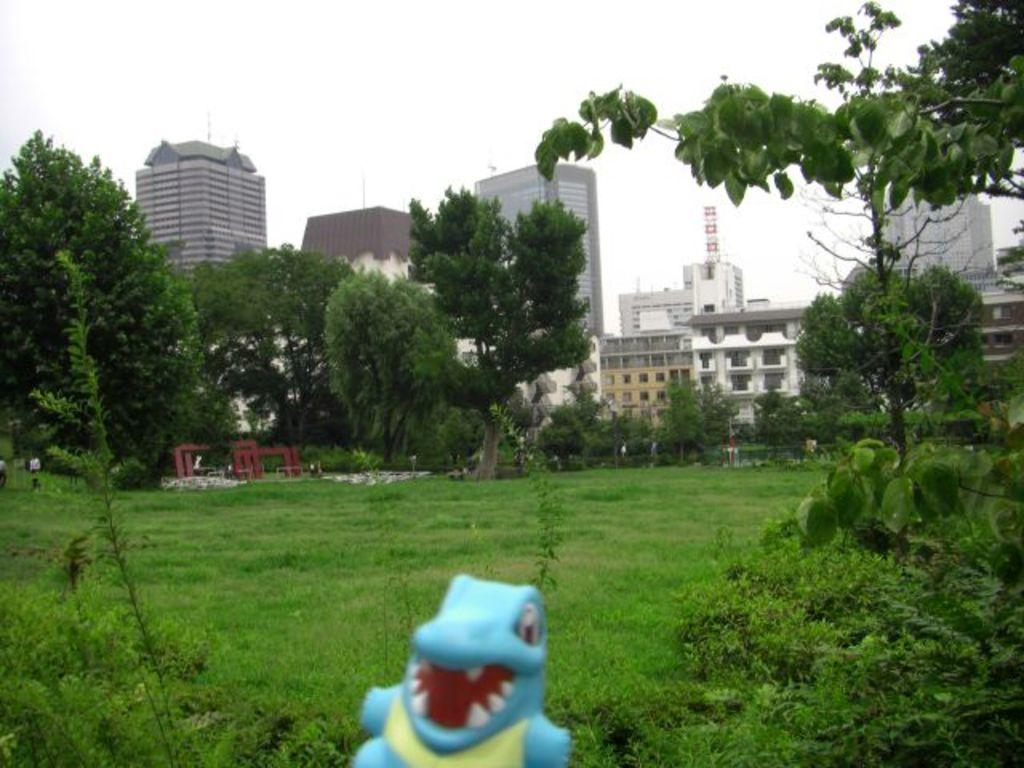What type of vegetation can be seen in the image? There are trees and plants in the image. What type of structures are present in the image? There are buildings in the image. What type of ground cover is visible in the image? There is grass in the image. What type of object can be seen that is not related to vegetation or buildings? There is a toy in the image. How many cats can be seen interacting with the toy in the image? There are no cats present in the image. What type of giant is visible in the image? There are no giants present in the image. 